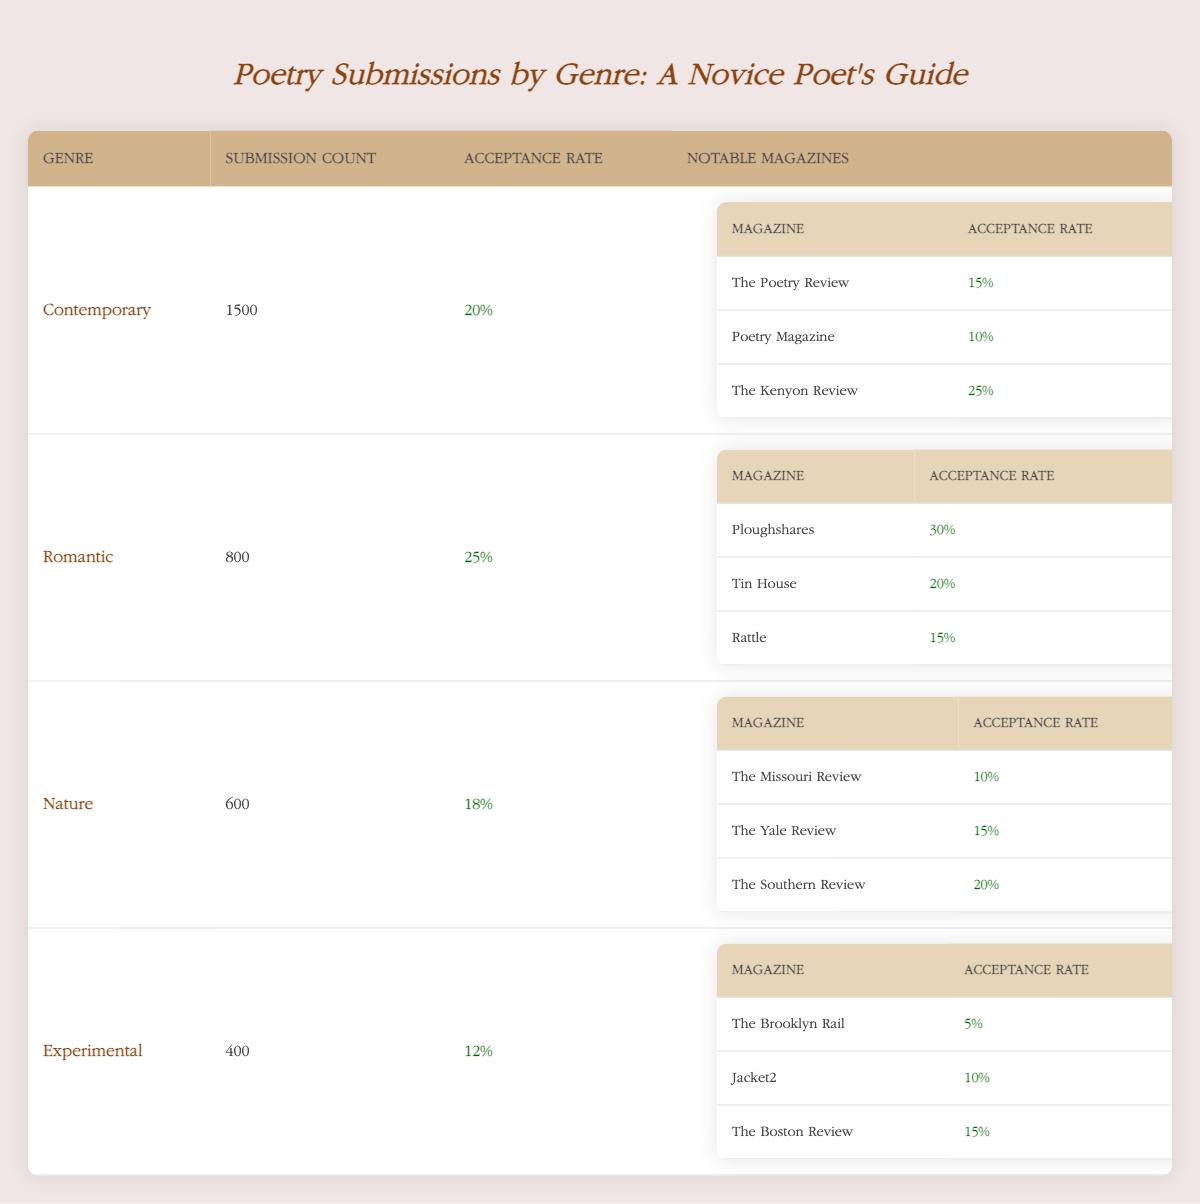What is the acceptance rate for Contemporary poetry submissions? The acceptance rate for Contemporary poetry submissions is directly listed in the table, which shows an acceptance rate of 20%.
Answer: 20% How many submissions were made for Romantic poetry? The number of submissions for Romantic poetry is found in the table under the "Submission Count" for that genre, which is 800.
Answer: 800 Which notable magazine has the highest acceptance rate for Nature poetry? By examining the notable magazines listed under Nature poetry, Ploughshares has the highest acceptance rate at 20%.
Answer: The Southern Review What is the average acceptance rate of the notable magazines under the Experimental genre? To find the average acceptance rate for the notable magazines under Experimental, we add the acceptance rates (5% + 10% + 15%) = 30% and divide by the number of magazines (3). Thus, 30%/3 = 10%.
Answer: 10% Is the acceptance rate for Romantic poetry higher than that for Contemporary poetry? Yes, the acceptance rate for Romantic poetry (25%) is higher than that for Contemporary poetry (20%), as shown in the table.
Answer: Yes What is the total submission count across all poetry genres? To find the total submission count, we add the submission counts for all genres: 1500 (Contemporary) + 800 (Romantic) + 600 (Nature) + 400 (Experimental) = 3300.
Answer: 3300 Which genre has the lowest acceptance rate and what is that rate? The genre with the lowest acceptance rate is Experimental, which has an acceptance rate of 12%, as indicated in the table.
Answer: 12% What percentage of the total submissions are for Contemporary poetry? To find the percentage, we take the submission count for Contemporary (1500) and divide it by the total submissions (3300), resulting in (1500/3300) * 100 ≈ 45.45%.
Answer: 45.45% Does Rattle have a higher acceptance rate than The Poetry Review? No, Rattle has an acceptance rate of 15%, while The Poetry Review has a lower acceptance rate of 15%, thus they are equal.
Answer: No 